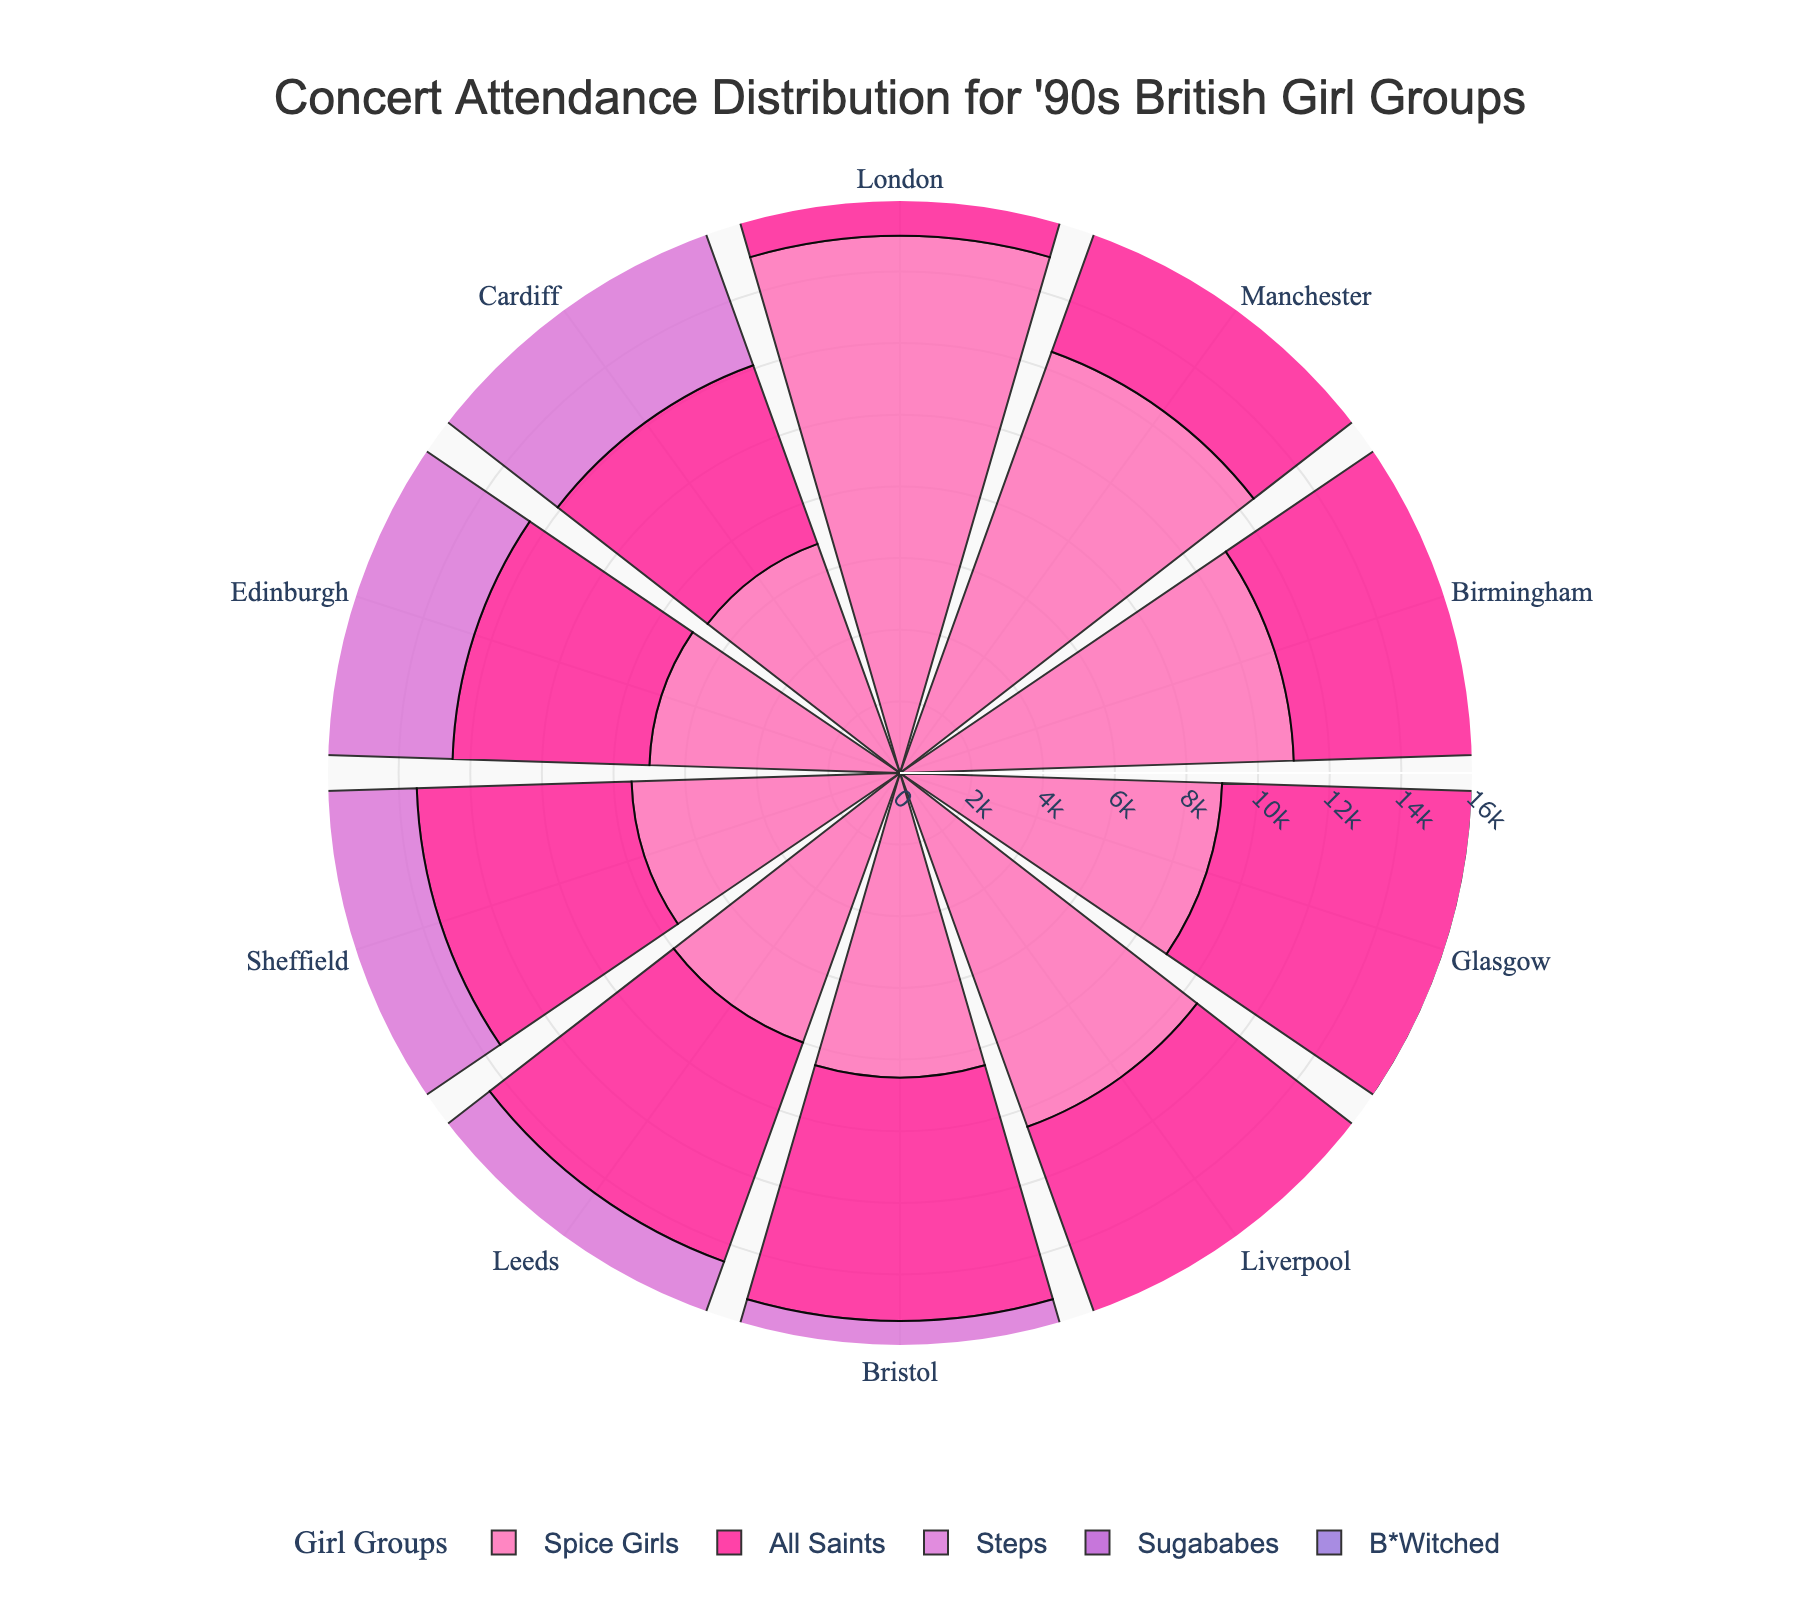Where did the Spice Girls have the highest concert attendance? Look at the slice for each city within the circle labeled Spice Girls. The longest slice is London.
Answer: London Which group had the highest concert attendance in Manchester? Compare the slices for Manchester for all groups. The longest slice is Spice Girls.
Answer: Spice Girls What is the total concert attendance for Steps across all cities? Sum the values for Steps in all cities: 14000 + 11000 + 9500 + 8000 + 9000 + 7500 + 7200 + 7000 + 6500 + 6400 = 89000
Answer: 89000 What is the average attendance for the Sugababes? Sum the attendance values for Sugababes across all cities and divide by the number of cities. The total sum is 10000 + 8500 + 7600 + 6500 + 7000 + 6000 + 5900 + 5500 + 5000 + 4800 = 72200. Divide by 10: 72200 / 10 = 7220
Answer: 7220 Which city had the lowest concert attendance for B*Witched? Observe the slices for B*Witched in each segment. The smallest slice is in Cardiff.
Answer: Cardiff How does the concert attendance for All Saints in Glasgow compare to their attendance in Bristol? Compare the heights of the slices for All Saints in Glasgow and Bristol. Glasgow is 7000, Bristol is 6800. 7000 is greater than 6800.
Answer: Glasgow is higher What is the combined attendance for All Saints and Sugababes in Birmingham? Add the attendance values for both groups in Birmingham: 8000 (All Saints) + 7600 (Sugababes) = 15600
Answer: 15600 Rank the cities by attendance for the Spice Girls from highest to lowest. List the attendance values for Spice Girls in each city and sort them: London (15000), Manchester (12500), Birmingham (11000), Liverpool (10500), Glasgow (9000), Bristol (8500), Leeds (8000), Sheffield (7500), Edinburgh (7000), Cardiff (6800)
Answer: London, Manchester, Birmingham, Liverpool, Glasgow, Bristol, Leeds, Sheffield, Edinburgh, Cardiff Which group has the most uniform distribution of attendance across the cities? Look for the group with the most consistent slice sizes across all cities. B*Witched slices appear relatively consistent across cities.
Answer: B*Witched 